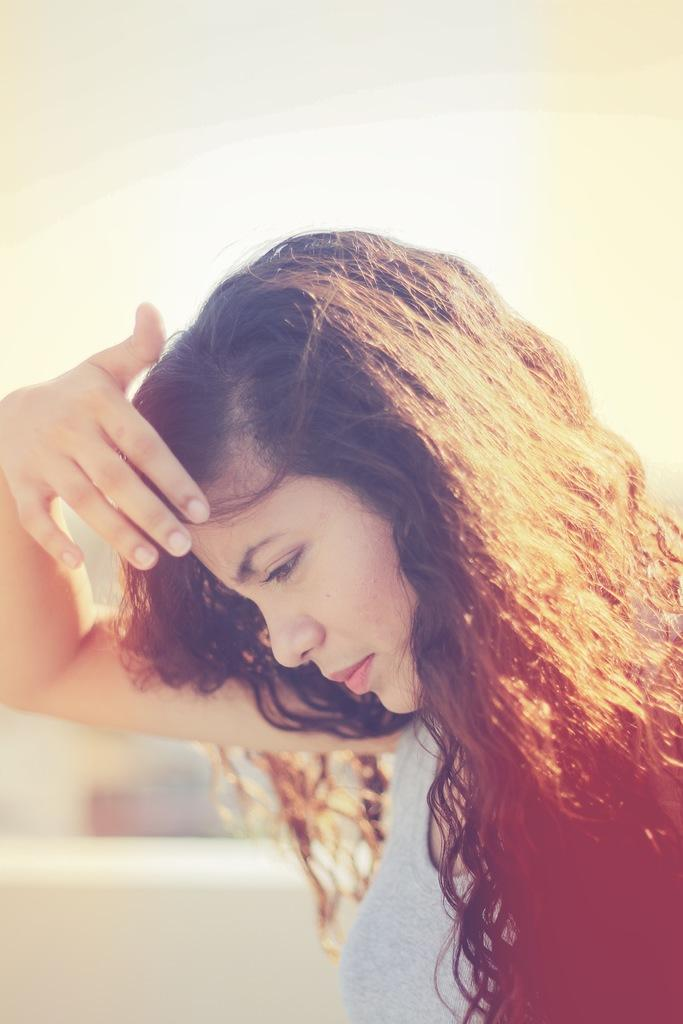Who is present in the image? There is a woman in the image. What is the woman wearing? The woman is wearing a grey t-shirt. What can be seen in the background of the image? There is a wall in the background of the image. How would you describe the quality of the image? The image is blurry. What is visible at the top of the image? The sky is visible at the top of the image. How many crows are perched on the wall in the image? There are no crows present in the image; it only features a woman wearing a grey t-shirt. What type of fowl can be seen in the image? There are no fowl present in the image. 